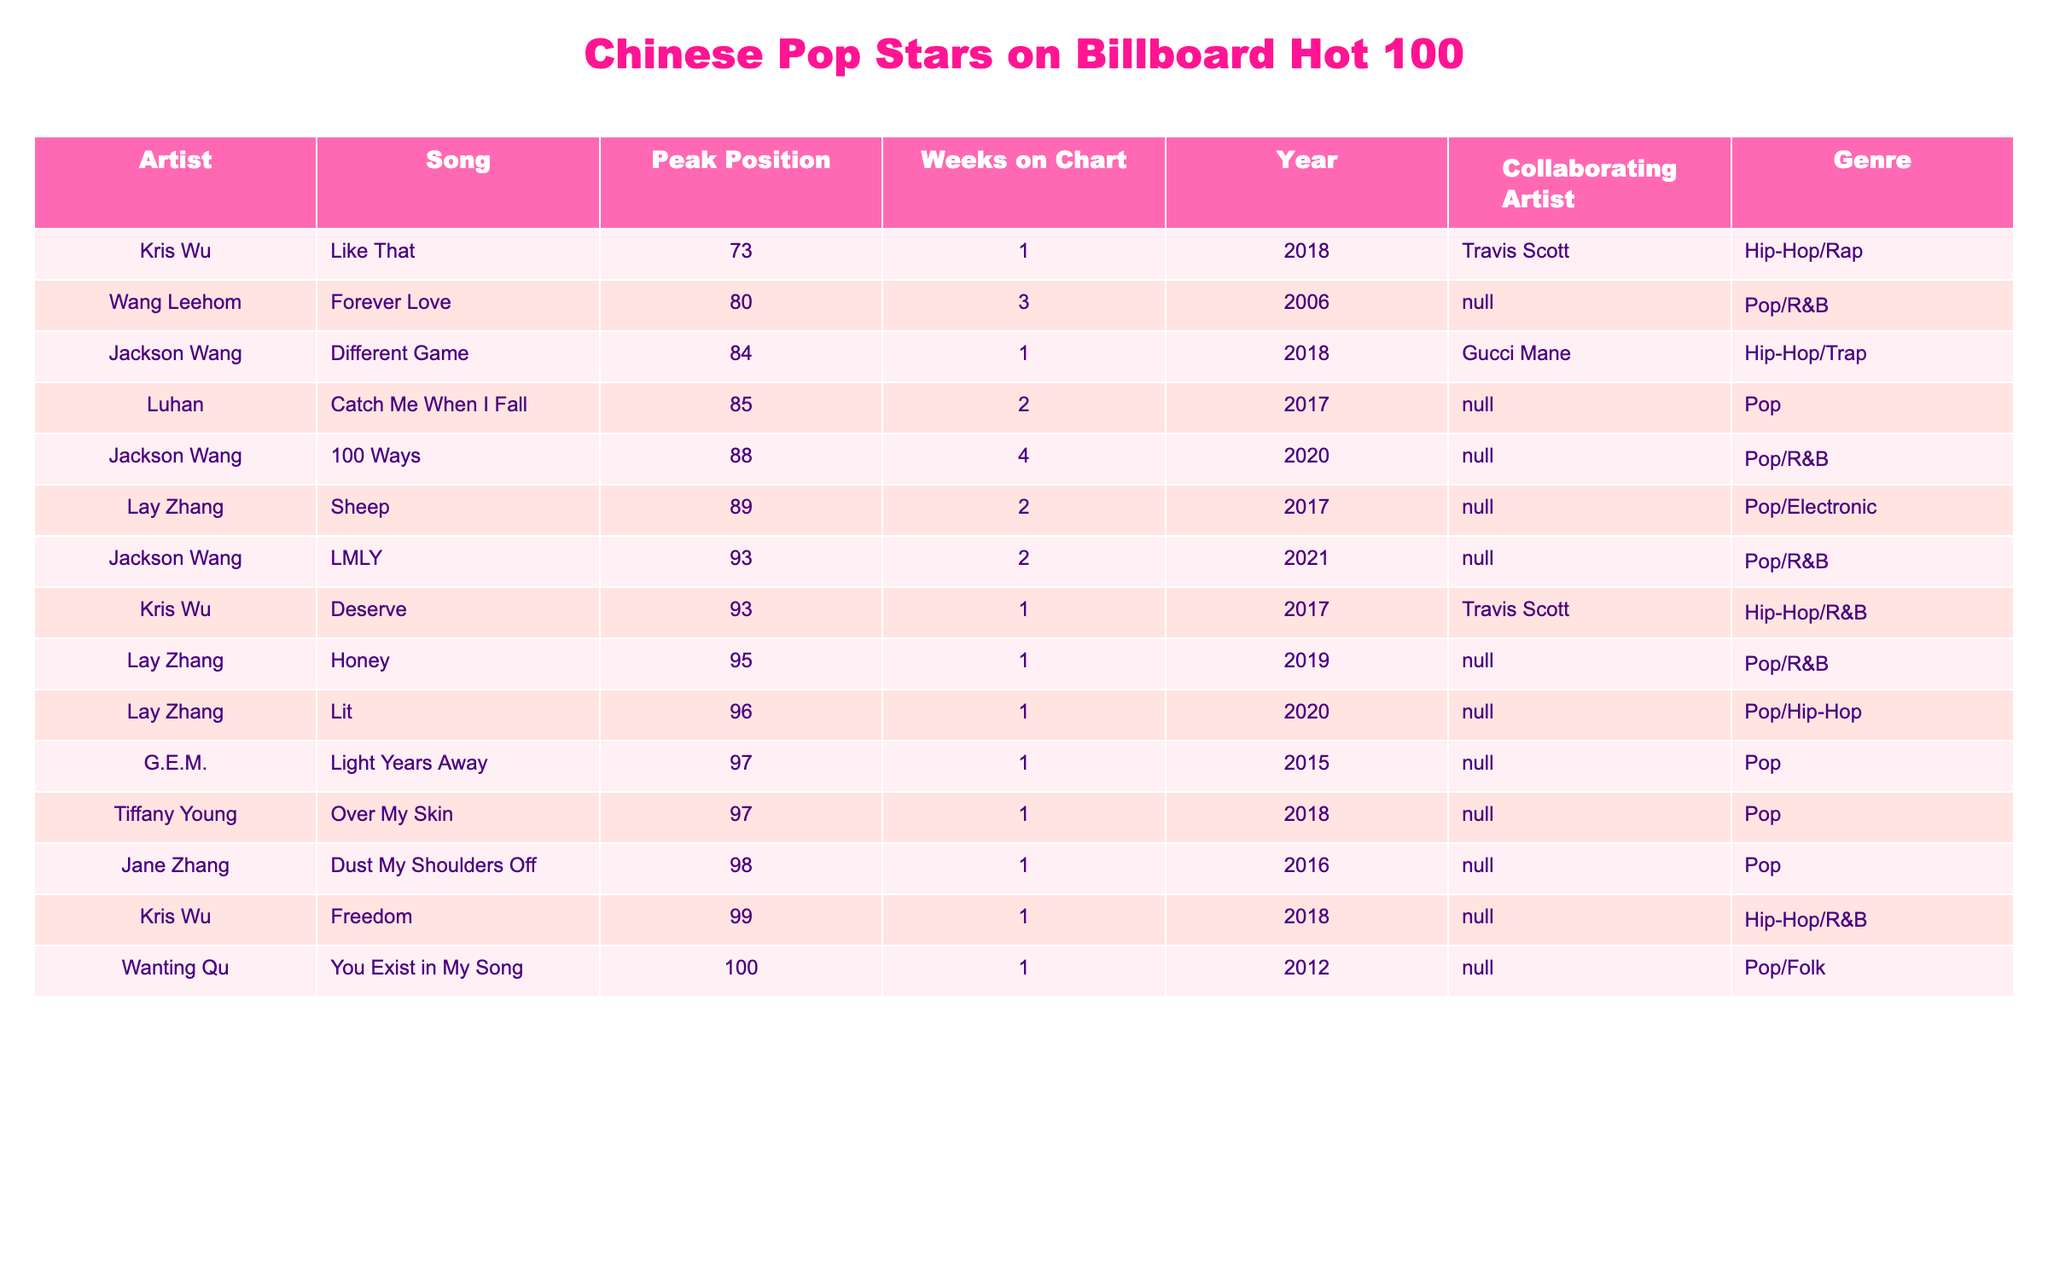What is the highest peak position achieved by a Chinese pop star on the Billboard Hot 100? By checking the "Peak Position" column in the table, the highest position is the lowest numerical value. The best peak position listed in the table is 73 for the song "Like That" by Kris Wu.
Answer: 73 How many weeks did Jackson Wang's song "100 Ways" spend on the chart? The table shows that "100 Ways" spent 4 weeks on the chart, which is directly stated in the "Weeks on Chart" column.
Answer: 4 Which artist has the most entries on the Billboard Hot 100 in this data? By counting the occurrences of each artist in the "Artist" column, we find Jackson Wang appears 3 times, Kris Wu also appears 3 times, while others appear fewer times. Both Jackson Wang and Kris Wu share the highest count of 3 entries each.
Answer: Jackson Wang and Kris Wu What is the average peak position of Lay Zhang's songs listed in the table? Lay Zhang has three songs listed with peak positions of 89, 96, and 95. To find the average, we sum these positions (89 + 96 + 95 = 280) and divide by the number of songs (3), giving us an average of 280 / 3 = 93.33.
Answer: 93.33 Did any songs by G.E.M. reach a peak position above 90? Looking at the "Peak Position" for G.E.M.'s song "Light Years Away," it is listed at 97. Since 97 is below 90, the answer is no; no songs by G.E.M. reached above 90.
Answer: No Which song had the lowest peak position, and who is the artist? The song with the lowest peak position is "You Exist in My Song" by Wanting Qu, listed at 100 in the "Peak Position" column.
Answer: You Exist in My Song by Wanting Qu What combined peak position do Kris Wu's songs achieve in the table? Kris Wu has three songs with peak positions of 73 (Like That), 93 (Deserve), and 99 (Freedom). The combined peak position totals are 73 + 93 + 99 = 265.
Answer: 265 How many of the listed songs peaked at positions below 90? By examining the "Peak Position" column, we find 6 songs peaked below 90. These are "100 Ways," "Like That," "Sheep," "LMLY," "Honey," and "Catch Me When I Fall."
Answer: 6 Is there a song by Tiffany Young, and what is its peak position? Looking for Tiffany Young in the "Artist" column, we see her song "Over My Skin," which reached a peak position of 97, as noted in the "Peak Position" column.
Answer: Yes, 97 Did Lay Zhang have any songs that peaked in the top 80? Analyzing Lay Zhang’s song peak positions, we see "Sheep" at 89, "Lit" at 96, and "Honey" at 95. None of these songs reached the top 80, therefore the answer is no.
Answer: No 